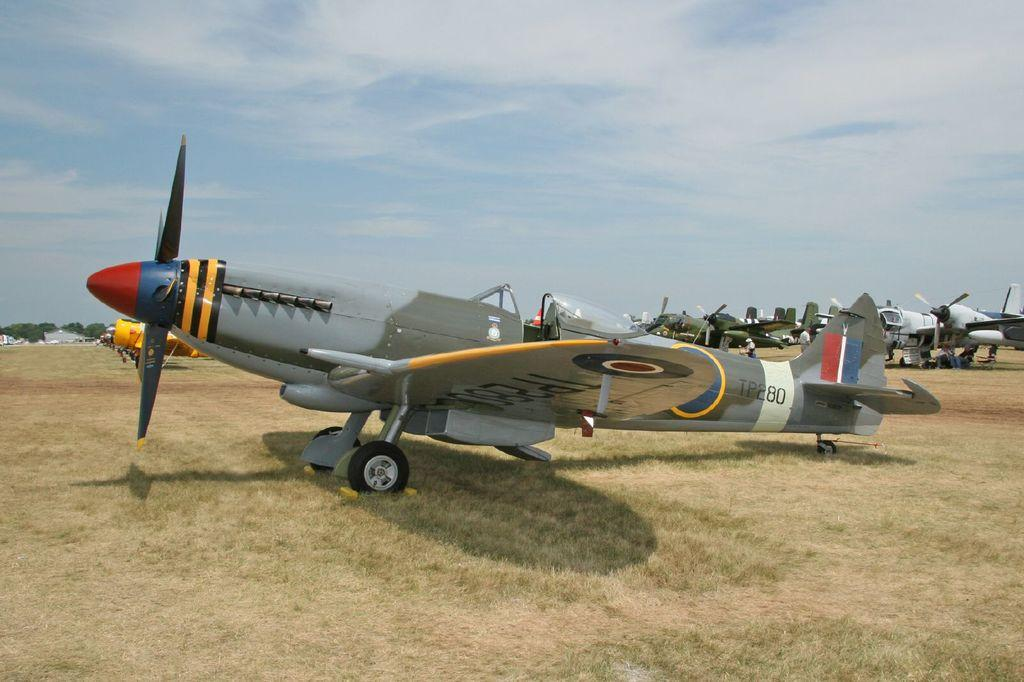What is the main subject of the picture? The main subject of the picture is airplanes. What type of terrain is visible in the picture? There is grass in the picture. What can be seen in the background of the picture? There are trees and the sky visible in the background of the picture. How many babies are playing with the canvas in the picture? There are no babies or canvas present in the picture; it features airplanes and a grassy terrain. What type of boat can be seen sailing in the background of the picture? There is no boat visible in the picture; it only shows airplanes, grass, trees, and the sky. 